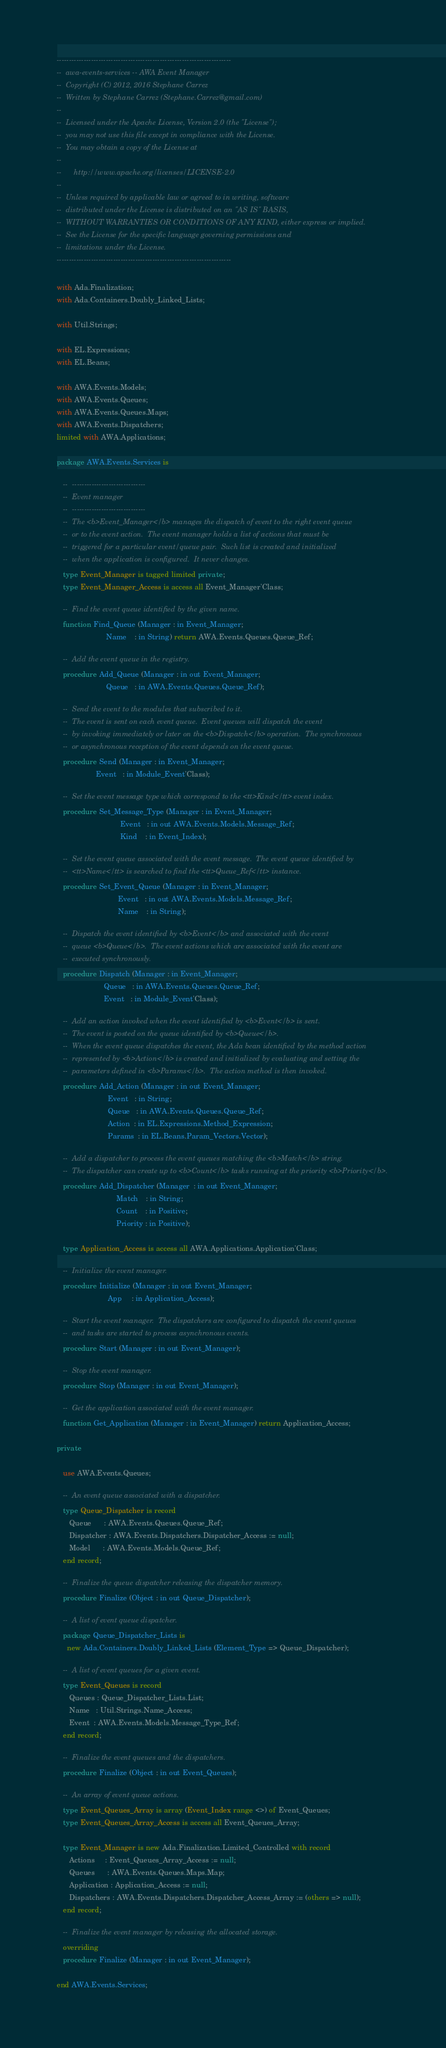<code> <loc_0><loc_0><loc_500><loc_500><_Ada_>-----------------------------------------------------------------------
--  awa-events-services -- AWA Event Manager
--  Copyright (C) 2012, 2016 Stephane Carrez
--  Written by Stephane Carrez (Stephane.Carrez@gmail.com)
--
--  Licensed under the Apache License, Version 2.0 (the "License");
--  you may not use this file except in compliance with the License.
--  You may obtain a copy of the License at
--
--      http://www.apache.org/licenses/LICENSE-2.0
--
--  Unless required by applicable law or agreed to in writing, software
--  distributed under the License is distributed on an "AS IS" BASIS,
--  WITHOUT WARRANTIES OR CONDITIONS OF ANY KIND, either express or implied.
--  See the License for the specific language governing permissions and
--  limitations under the License.
-----------------------------------------------------------------------

with Ada.Finalization;
with Ada.Containers.Doubly_Linked_Lists;

with Util.Strings;

with EL.Expressions;
with EL.Beans;

with AWA.Events.Models;
with AWA.Events.Queues;
with AWA.Events.Queues.Maps;
with AWA.Events.Dispatchers;
limited with AWA.Applications;

package AWA.Events.Services is

   --  ------------------------------
   --  Event manager
   --  ------------------------------
   --  The <b>Event_Manager</b> manages the dispatch of event to the right event queue
   --  or to the event action.  The event manager holds a list of actions that must be
   --  triggered for a particular event/queue pair.  Such list is created and initialized
   --  when the application is configured.  It never changes.
   type Event_Manager is tagged limited private;
   type Event_Manager_Access is access all Event_Manager'Class;

   --  Find the event queue identified by the given name.
   function Find_Queue (Manager : in Event_Manager;
                        Name    : in String) return AWA.Events.Queues.Queue_Ref;

   --  Add the event queue in the registry.
   procedure Add_Queue (Manager : in out Event_Manager;
                        Queue   : in AWA.Events.Queues.Queue_Ref);

   --  Send the event to the modules that subscribed to it.
   --  The event is sent on each event queue.  Event queues will dispatch the event
   --  by invoking immediately or later on the <b>Dispatch</b> operation.  The synchronous
   --  or asynchronous reception of the event depends on the event queue.
   procedure Send (Manager : in Event_Manager;
                   Event   : in Module_Event'Class);

   --  Set the event message type which correspond to the <tt>Kind</tt> event index.
   procedure Set_Message_Type (Manager : in Event_Manager;
                               Event   : in out AWA.Events.Models.Message_Ref;
                               Kind    : in Event_Index);

   --  Set the event queue associated with the event message.  The event queue identified by
   --  <tt>Name</tt> is searched to find the <tt>Queue_Ref</tt> instance.
   procedure Set_Event_Queue (Manager : in Event_Manager;
                              Event   : in out AWA.Events.Models.Message_Ref;
                              Name    : in String);

   --  Dispatch the event identified by <b>Event</b> and associated with the event
   --  queue <b>Queue</b>.  The event actions which are associated with the event are
   --  executed synchronously.
   procedure Dispatch (Manager : in Event_Manager;
                       Queue   : in AWA.Events.Queues.Queue_Ref;
                       Event   : in Module_Event'Class);

   --  Add an action invoked when the event identified by <b>Event</b> is sent.
   --  The event is posted on the queue identified by <b>Queue</b>.
   --  When the event queue dispatches the event, the Ada bean identified by the method action
   --  represented by <b>Action</b> is created and initialized by evaluating and setting the
   --  parameters defined in <b>Params</b>.  The action method is then invoked.
   procedure Add_Action (Manager : in out Event_Manager;
                         Event   : in String;
                         Queue   : in AWA.Events.Queues.Queue_Ref;
                         Action  : in EL.Expressions.Method_Expression;
                         Params  : in EL.Beans.Param_Vectors.Vector);

   --  Add a dispatcher to process the event queues matching the <b>Match</b> string.
   --  The dispatcher can create up to <b>Count</b> tasks running at the priority <b>Priority</b>.
   procedure Add_Dispatcher (Manager  : in out Event_Manager;
                             Match    : in String;
                             Count    : in Positive;
                             Priority : in Positive);

   type Application_Access is access all AWA.Applications.Application'Class;

   --  Initialize the event manager.
   procedure Initialize (Manager : in out Event_Manager;
                         App     : in Application_Access);

   --  Start the event manager.  The dispatchers are configured to dispatch the event queues
   --  and tasks are started to process asynchronous events.
   procedure Start (Manager : in out Event_Manager);

   --  Stop the event manager.
   procedure Stop (Manager : in out Event_Manager);

   --  Get the application associated with the event manager.
   function Get_Application (Manager : in Event_Manager) return Application_Access;

private

   use AWA.Events.Queues;

   --  An event queue associated with a dispatcher.
   type Queue_Dispatcher is record
      Queue      : AWA.Events.Queues.Queue_Ref;
      Dispatcher : AWA.Events.Dispatchers.Dispatcher_Access := null;
      Model      : AWA.Events.Models.Queue_Ref;
   end record;

   --  Finalize the queue dispatcher releasing the dispatcher memory.
   procedure Finalize (Object : in out Queue_Dispatcher);

   --  A list of event queue dispatcher.
   package Queue_Dispatcher_Lists is
     new Ada.Containers.Doubly_Linked_Lists (Element_Type => Queue_Dispatcher);

   --  A list of event queues for a given event.
   type Event_Queues is record
      Queues : Queue_Dispatcher_Lists.List;
      Name   : Util.Strings.Name_Access;
      Event  : AWA.Events.Models.Message_Type_Ref;
   end record;

   --  Finalize the event queues and the dispatchers.
   procedure Finalize (Object : in out Event_Queues);

   --  An array of event queue actions.
   type Event_Queues_Array is array (Event_Index range <>) of Event_Queues;
   type Event_Queues_Array_Access is access all Event_Queues_Array;

   type Event_Manager is new Ada.Finalization.Limited_Controlled with record
      Actions     : Event_Queues_Array_Access := null;
      Queues      : AWA.Events.Queues.Maps.Map;
      Application : Application_Access := null;
      Dispatchers : AWA.Events.Dispatchers.Dispatcher_Access_Array := (others => null);
   end record;

   --  Finalize the event manager by releasing the allocated storage.
   overriding
   procedure Finalize (Manager : in out Event_Manager);

end AWA.Events.Services;
</code> 